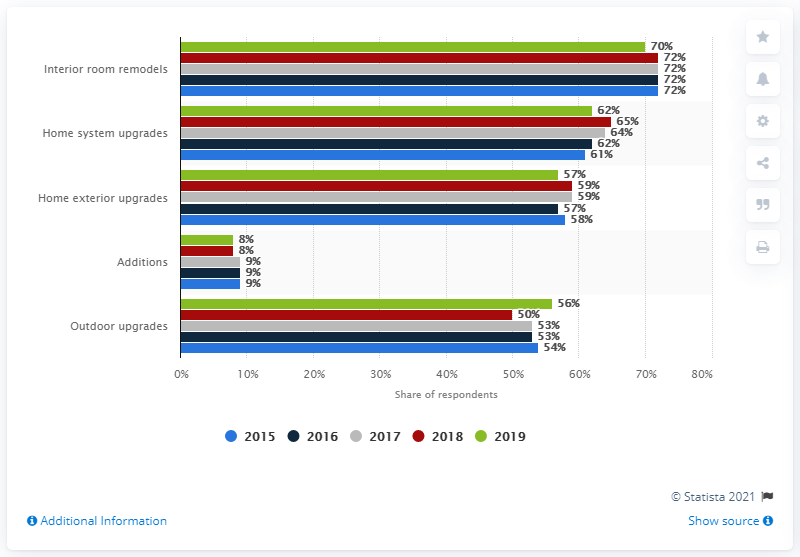Give some essential details in this illustration. The chart represents approximately 5 years of data. The sum of all five years in additions is 43. 